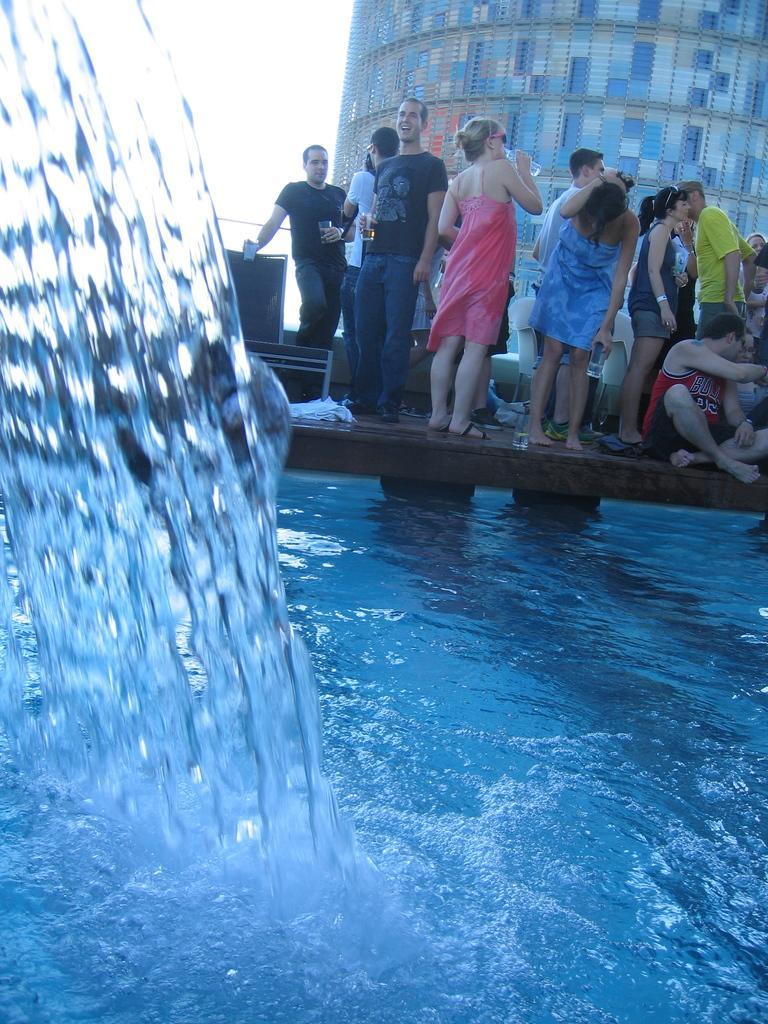How would you summarize this image in a sentence or two? In the image there is water in the foreground and behind the water there is a bridge and on that there are few people. 